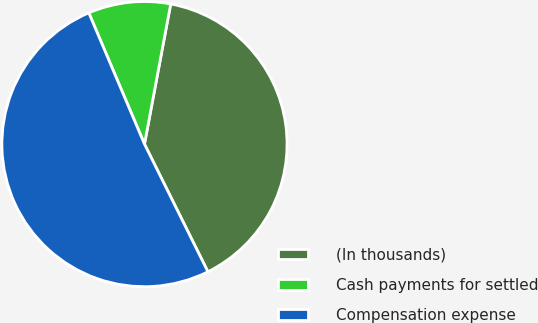Convert chart. <chart><loc_0><loc_0><loc_500><loc_500><pie_chart><fcel>(In thousands)<fcel>Cash payments for settled<fcel>Compensation expense<nl><fcel>39.71%<fcel>9.33%<fcel>50.95%<nl></chart> 